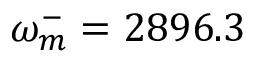<formula> <loc_0><loc_0><loc_500><loc_500>\omega _ { m } ^ { - } = 2 8 9 6 . 3</formula> 